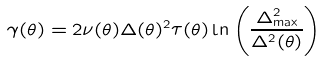<formula> <loc_0><loc_0><loc_500><loc_500>\gamma ( \theta ) = 2 \nu ( \theta ) \Delta ( \theta ) ^ { 2 } \tau ( \theta ) \ln \left ( \frac { \Delta _ { \max } ^ { 2 } } { \Delta ^ { 2 } ( \theta ) } \right )</formula> 